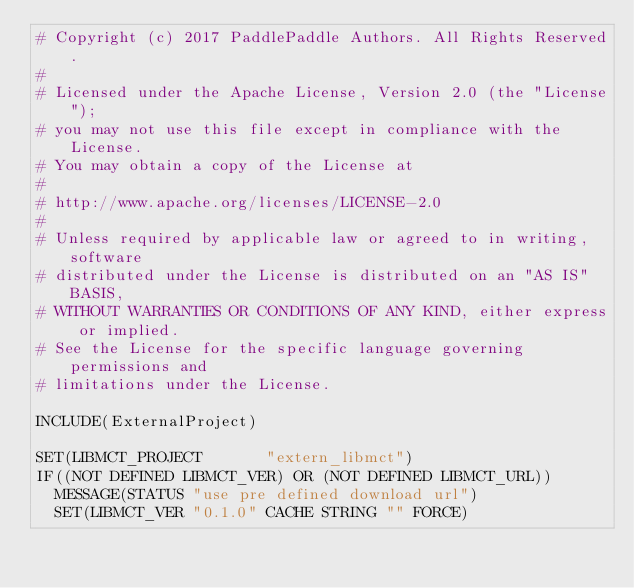Convert code to text. <code><loc_0><loc_0><loc_500><loc_500><_CMake_># Copyright (c) 2017 PaddlePaddle Authors. All Rights Reserved.
#
# Licensed under the Apache License, Version 2.0 (the "License");
# you may not use this file except in compliance with the License.
# You may obtain a copy of the License at
#
# http://www.apache.org/licenses/LICENSE-2.0
#
# Unless required by applicable law or agreed to in writing, software
# distributed under the License is distributed on an "AS IS" BASIS,
# WITHOUT WARRANTIES OR CONDITIONS OF ANY KIND, either express or implied.
# See the License for the specific language governing permissions and
# limitations under the License.

INCLUDE(ExternalProject)

SET(LIBMCT_PROJECT       "extern_libmct")
IF((NOT DEFINED LIBMCT_VER) OR (NOT DEFINED LIBMCT_URL))
  MESSAGE(STATUS "use pre defined download url")
  SET(LIBMCT_VER "0.1.0" CACHE STRING "" FORCE)</code> 